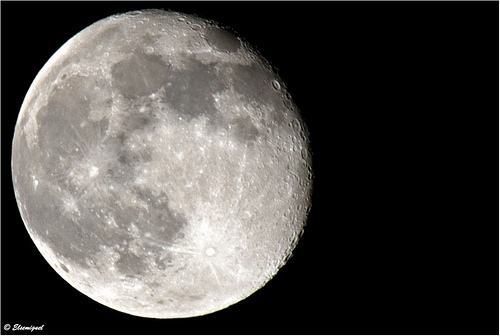<image>
Can you confirm if the daytime moon is in the daylight sky? No. The daytime moon is not contained within the daylight sky. These objects have a different spatial relationship. 